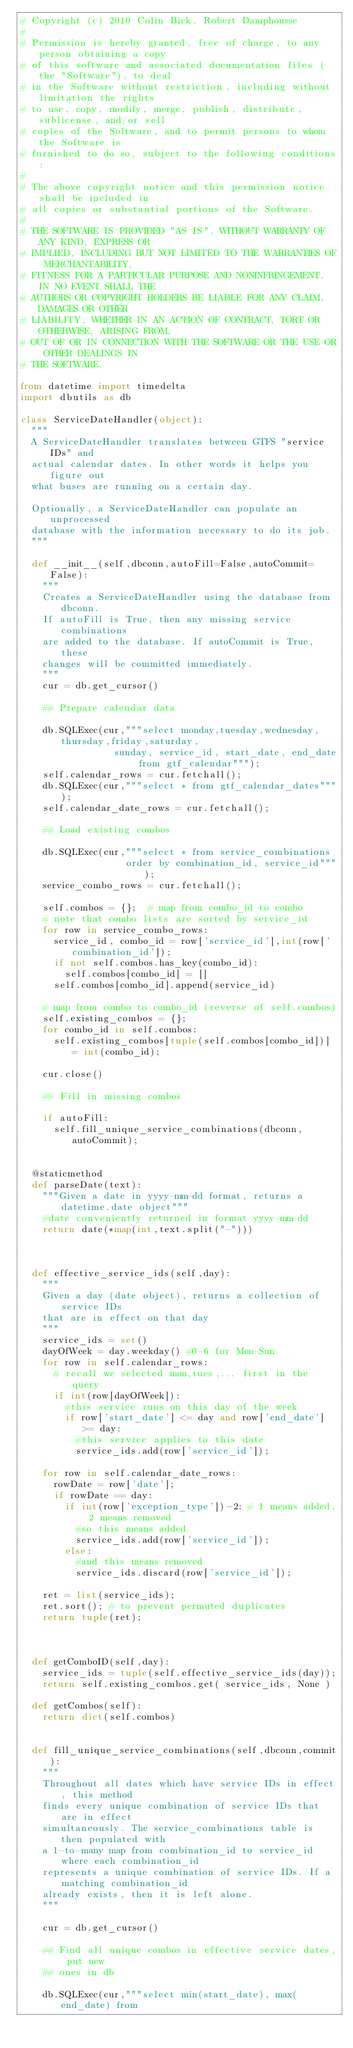<code> <loc_0><loc_0><loc_500><loc_500><_Python_># Copyright (c) 2010 Colin Bick, Robert Damphousse
#
# Permission is hereby granted, free of charge, to any person obtaining a copy
# of this software and associated documentation files (the "Software"), to deal
# in the Software without restriction, including without limitation the rights
# to use, copy, modify, merge, publish, distribute, sublicense, and/or sell
# copies of the Software, and to permit persons to whom the Software is
# furnished to do so, subject to the following conditions:
#
# The above copyright notice and this permission notice shall be included in
# all copies or substantial portions of the Software.
#
# THE SOFTWARE IS PROVIDED "AS IS", WITHOUT WARRANTY OF ANY KIND, EXPRESS OR
# IMPLIED, INCLUDING BUT NOT LIMITED TO THE WARRANTIES OF MERCHANTABILITY,
# FITNESS FOR A PARTICULAR PURPOSE AND NONINFRINGEMENT. IN NO EVENT SHALL THE
# AUTHORS OR COPYRIGHT HOLDERS BE LIABLE FOR ANY CLAIM, DAMAGES OR OTHER
# LIABILITY, WHETHER IN AN ACTION OF CONTRACT, TORT OR OTHERWISE, ARISING FROM,
# OUT OF OR IN CONNECTION WITH THE SOFTWARE OR THE USE OR OTHER DEALINGS IN
# THE SOFTWARE.

from datetime import timedelta
import dbutils as db

class ServiceDateHandler(object):
  """
  A ServiceDateHandler translates between GTFS "service IDs" and
  actual calendar dates. In other words it helps you figure out
  what buses are running on a certain day.

  Optionally, a ServiceDateHandler can populate an unprocessed 
  database with the information necessary to do its job.
  """
  
  def __init__(self,dbconn,autoFill=False,autoCommit=False):
    """
    Creates a ServiceDateHandler using the database from dbconn.
    If autoFill is True, then any missing service combinations
    are added to the database. If autoCommit is True, these
    changes will be committed immediately.
    """
    cur = db.get_cursor()

    ## Prepare calendar data
    
    db.SQLExec(cur,"""select monday,tuesday,wednesday,thursday,friday,saturday,
                 sunday, service_id, start_date, end_date from gtf_calendar""");
    self.calendar_rows = cur.fetchall();
    db.SQLExec(cur,"""select * from gtf_calendar_dates""");
    self.calendar_date_rows = cur.fetchall();

    ## Load existing combos

    db.SQLExec(cur,"""select * from service_combinations 
                   order by combination_id, service_id""");
    service_combo_rows = cur.fetchall();

    self.combos = {};  # map from combo_id to combo
    # note that combo lists are sorted by service_id
    for row in service_combo_rows:
      service_id, combo_id = row['service_id'],int(row['combination_id']);
      if not self.combos.has_key(combo_id):
        self.combos[combo_id] = []
      self.combos[combo_id].append(service_id)

    # map from combo to combo_id (reverse of self.combos)
    self.existing_combos = {}; 
    for combo_id in self.combos:
      self.existing_combos[tuple(self.combos[combo_id])] = int(combo_id);
    
    cur.close()

    ## Fill in missing combos

    if autoFill:
      self.fill_unique_service_combinations(dbconn,autoCommit);


  @staticmethod
  def parseDate(text):
    """Given a date in yyyy-mm-dd format, returns a datetime.date object"""
    #date conveniently returned in format yyyy-mm-dd
    return date(*map(int,text.split("-")))



  def effective_service_ids(self,day):
    """
    Given a day (date object), returns a collection of service IDs
    that are in effect on that day
    """
    service_ids = set()
    dayOfWeek = day.weekday() #0-6 for Mon-Sun
    for row in self.calendar_rows:     
      # recall we selected mon,tues,... first in the query
      if int(row[dayOfWeek]):
        #this service runs on this day of the week
        if row['start_date'] <= day and row['end_date'] >= day: 
          #this service applies to this date
          service_ids.add(row['service_id']);

    for row in self.calendar_date_rows:
      rowDate = row['date'];
      if rowDate == day:
        if int(row['exception_type'])-2: # 1 means added, 2 means removed
          #so this means added
          service_ids.add(row['service_id']);
        else:
          #and this means removed
          service_ids.discard(row['service_id']);
          
    ret = list(service_ids);
    ret.sort(); # to prevent permuted duplicates
    return tuple(ret);



  def getComboID(self,day):
    service_ids = tuple(self.effective_service_ids(day));
    return self.existing_combos.get( service_ids, None )

  def getCombos(self):
    return dict(self.combos)


  def fill_unique_service_combinations(self,dbconn,commit):
    """
    Throughout all dates which have service IDs in effect, this method
    finds every unique combination of service IDs that are in effect
    simultaneously. The service_combinations table is then populated with
    a 1-to-many map from combination_id to service_id where each combination_id
    represents a unique combination of service IDs. If a matching combination_id
    already exists, then it is left alone.
    """

    cur = db.get_cursor()  
  
    ## Find all unique combos in effective service dates, put new
    ## ones in db

    db.SQLExec(cur,"""select min(start_date), max(end_date) from </code> 